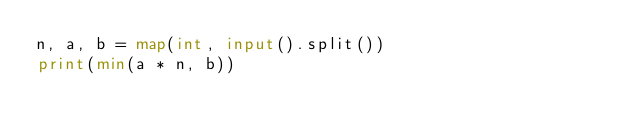<code> <loc_0><loc_0><loc_500><loc_500><_Python_>n, a, b = map(int, input().split())
print(min(a * n, b))</code> 